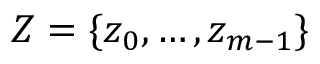<formula> <loc_0><loc_0><loc_500><loc_500>Z = \{ z _ { 0 } , \dots , z _ { m - 1 } \}</formula> 